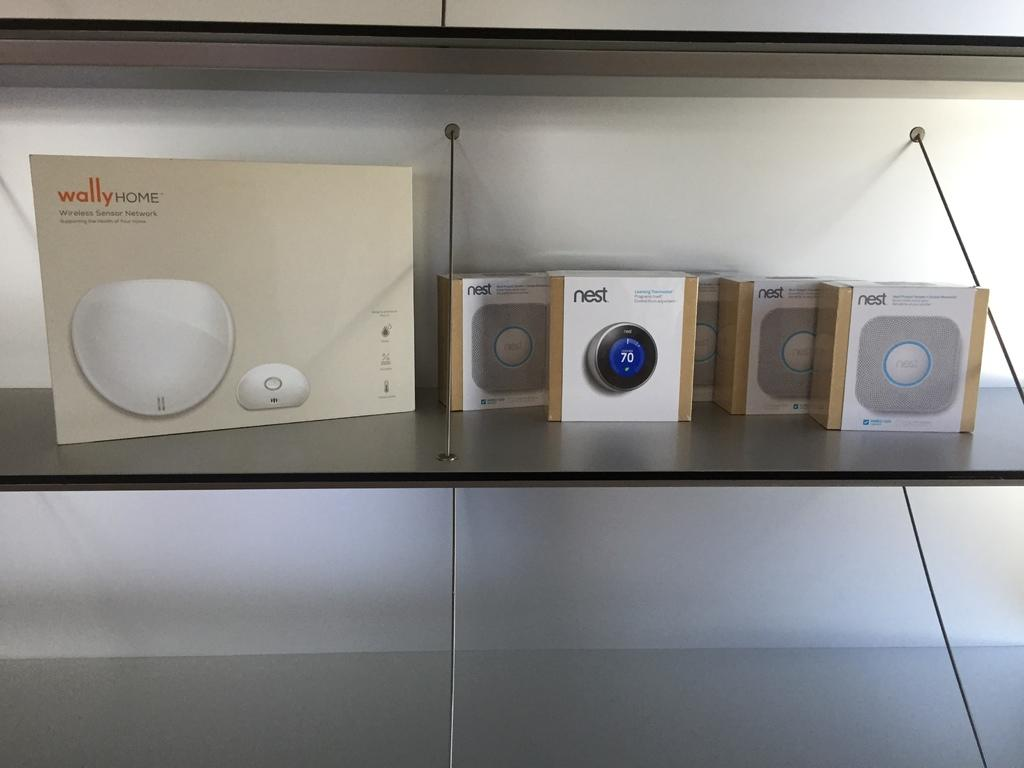What objects are on the shelf in the image? There are boxes on a shelf in the image. What can be seen in the background of the image? There is a wall in the background of the image. What type of calculator is being used on the shelf in the image? There is no calculator present in the image; it only shows boxes on a shelf and a wall in the background. 